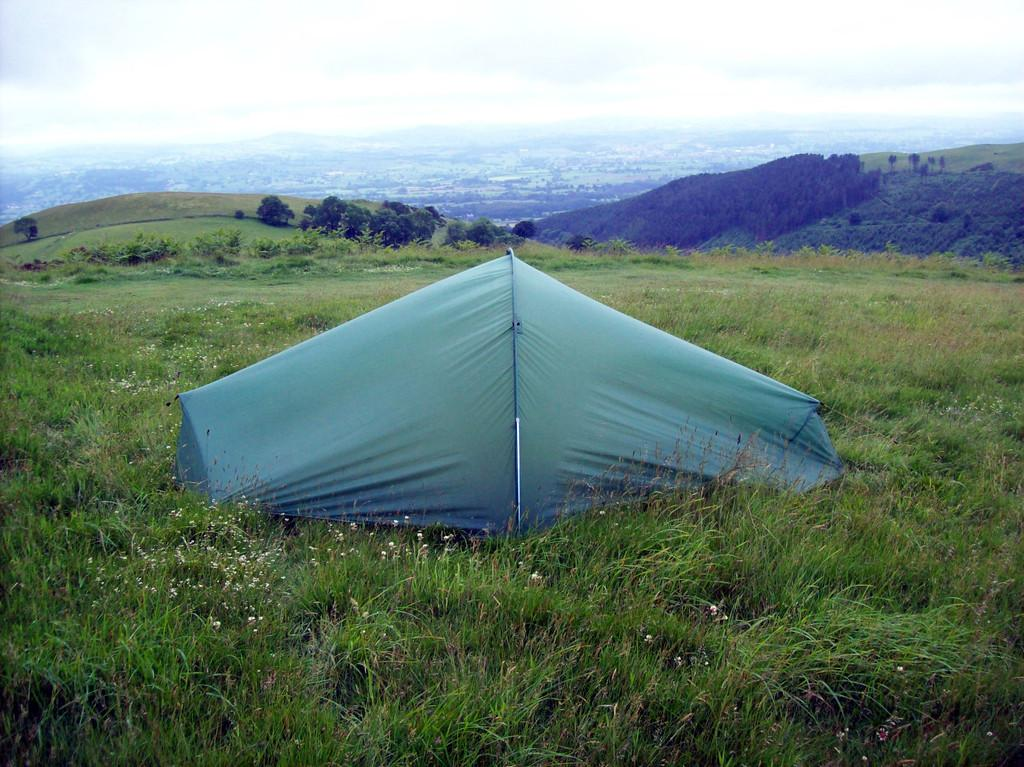What structure can be seen in the image? There is a tent in the image. What type of vegetation is visible in the image? There is grass with flowers in the image. What can be seen in the background of the image? There are mountains in the background of the image. What is growing on the mountains? Trees are present on the mountains. What is the condition of the sky in the image? The sky is clear in the image. How many clocks are hanging on the trees in the image? There are no clocks present in the image; it features a tent, grass, flowers, mountains, and trees. What type of scene is depicted on the back of the tent in the image? There is no scene depicted on the back of the tent in the image, as the facts provided do not mention any such detail. 